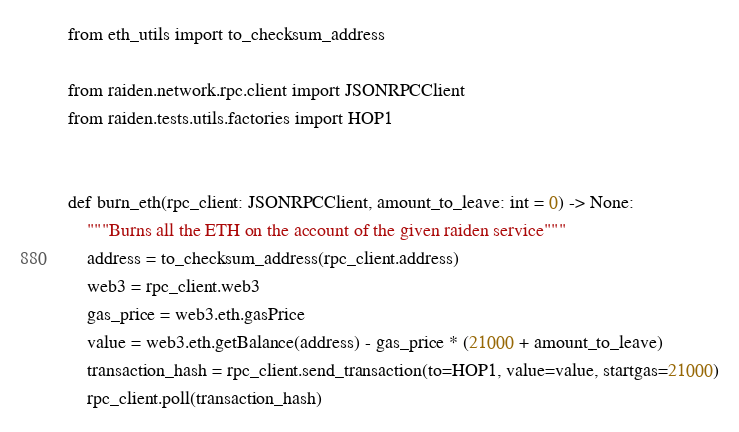<code> <loc_0><loc_0><loc_500><loc_500><_Python_>from eth_utils import to_checksum_address

from raiden.network.rpc.client import JSONRPCClient
from raiden.tests.utils.factories import HOP1


def burn_eth(rpc_client: JSONRPCClient, amount_to_leave: int = 0) -> None:
    """Burns all the ETH on the account of the given raiden service"""
    address = to_checksum_address(rpc_client.address)
    web3 = rpc_client.web3
    gas_price = web3.eth.gasPrice
    value = web3.eth.getBalance(address) - gas_price * (21000 + amount_to_leave)
    transaction_hash = rpc_client.send_transaction(to=HOP1, value=value, startgas=21000)
    rpc_client.poll(transaction_hash)
</code> 